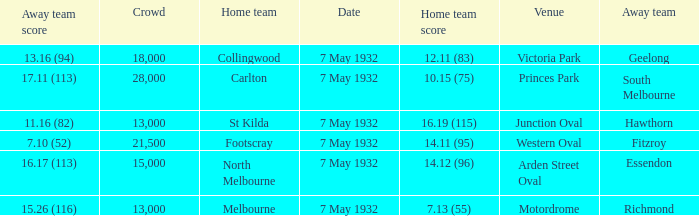What is the home team for victoria park? Collingwood. 